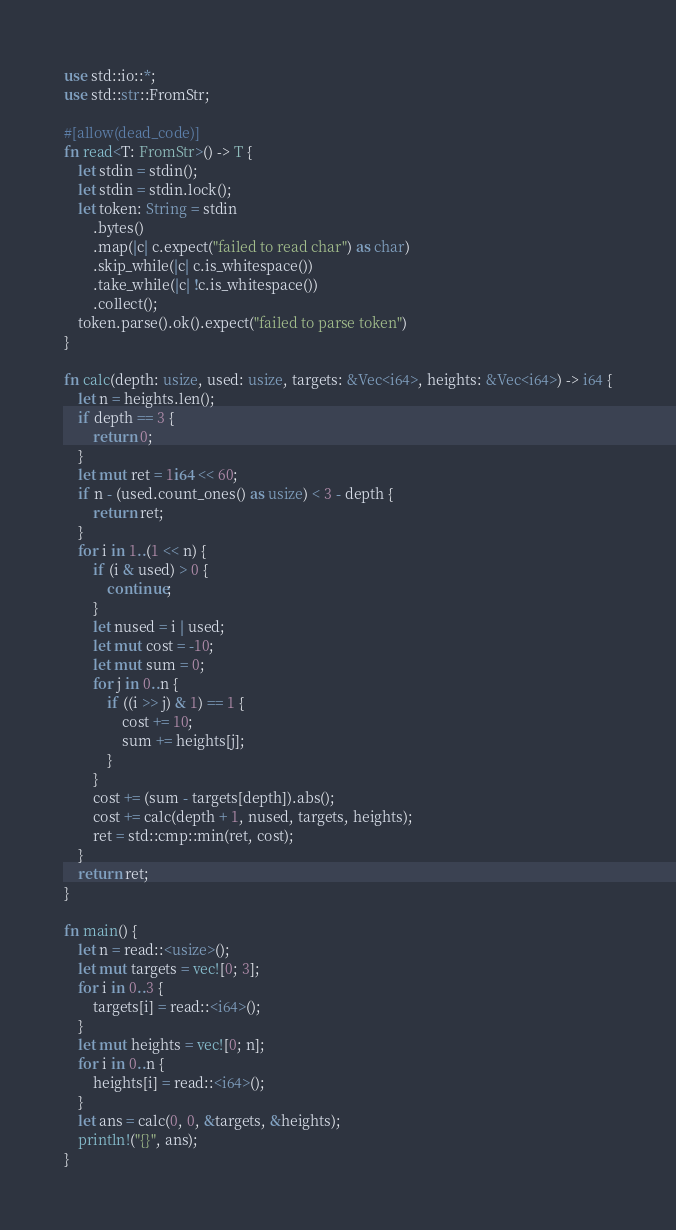Convert code to text. <code><loc_0><loc_0><loc_500><loc_500><_Rust_>use std::io::*;
use std::str::FromStr;

#[allow(dead_code)]
fn read<T: FromStr>() -> T {
    let stdin = stdin();
    let stdin = stdin.lock();
    let token: String = stdin
        .bytes()
        .map(|c| c.expect("failed to read char") as char)
        .skip_while(|c| c.is_whitespace())
        .take_while(|c| !c.is_whitespace())
        .collect();
    token.parse().ok().expect("failed to parse token")
}

fn calc(depth: usize, used: usize, targets: &Vec<i64>, heights: &Vec<i64>) -> i64 {
    let n = heights.len();
    if depth == 3 {
        return 0;
    }
    let mut ret = 1i64 << 60;
    if n - (used.count_ones() as usize) < 3 - depth {
        return ret;
    }
    for i in 1..(1 << n) {
        if (i & used) > 0 {
            continue;
        }
        let nused = i | used;
        let mut cost = -10;
        let mut sum = 0;
        for j in 0..n {
            if ((i >> j) & 1) == 1 {
                cost += 10;
                sum += heights[j];
            }
        }
        cost += (sum - targets[depth]).abs();
        cost += calc(depth + 1, nused, targets, heights);
        ret = std::cmp::min(ret, cost);
    }
    return ret;
}

fn main() {
    let n = read::<usize>();
    let mut targets = vec![0; 3];
    for i in 0..3 {
        targets[i] = read::<i64>();
    }
    let mut heights = vec![0; n];
    for i in 0..n {
        heights[i] = read::<i64>();
    }
    let ans = calc(0, 0, &targets, &heights);
    println!("{}", ans);
}
</code> 